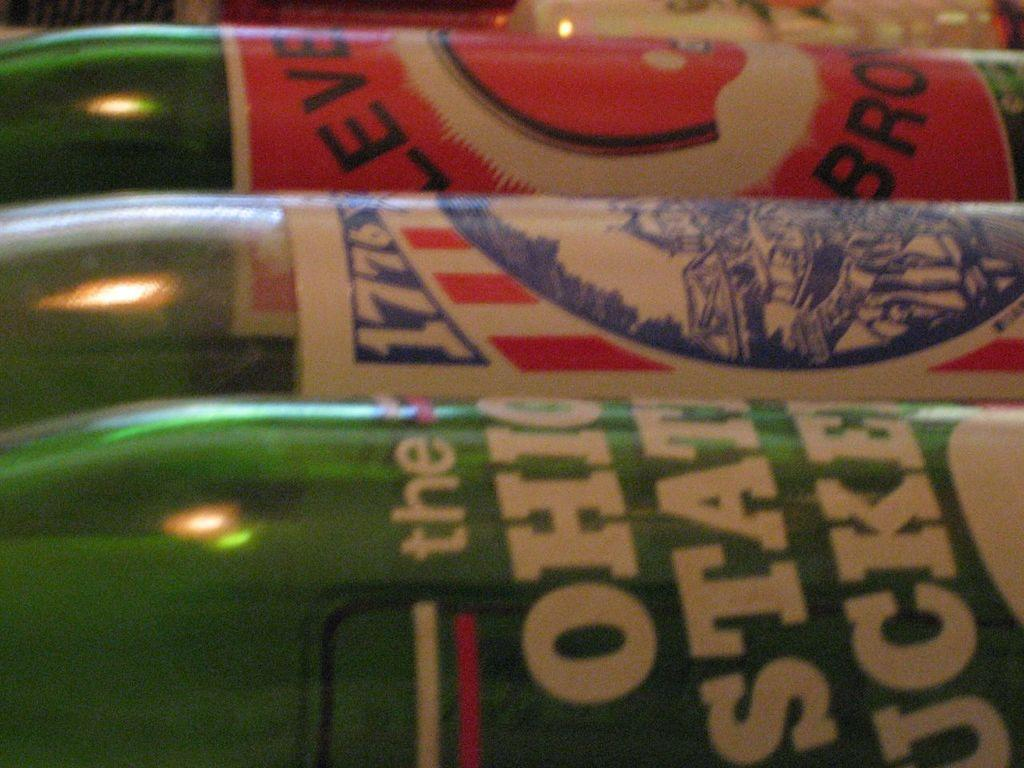<image>
Offer a succinct explanation of the picture presented. Several bottles are on their side including one that has the date of 1776 on it. 